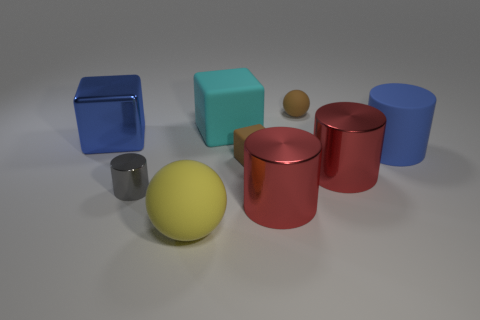Subtract all blue cylinders. How many cylinders are left? 3 Subtract all red blocks. How many red cylinders are left? 2 Subtract 1 cylinders. How many cylinders are left? 3 Subtract all blue cylinders. How many cylinders are left? 3 Add 1 tiny brown rubber objects. How many objects exist? 10 Subtract all blocks. Subtract all gray things. How many objects are left? 5 Add 9 cyan matte objects. How many cyan matte objects are left? 10 Add 7 cyan objects. How many cyan objects exist? 8 Subtract 1 brown spheres. How many objects are left? 8 Subtract all spheres. How many objects are left? 7 